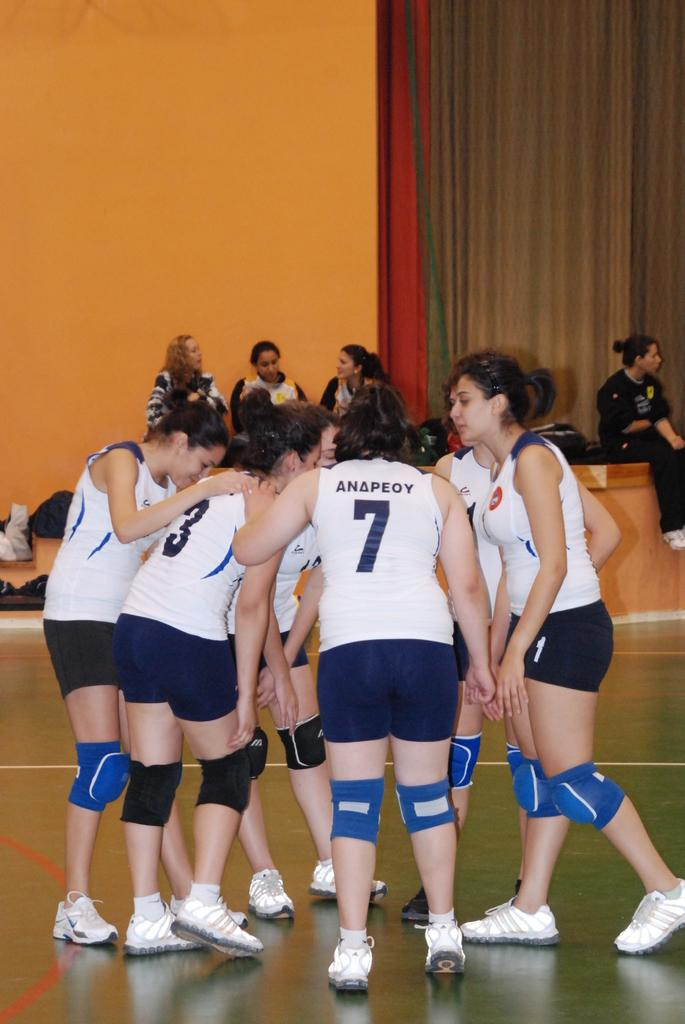<image>
Relay a brief, clear account of the picture shown. A team of volleyball players are huddled in a circle including number 3 and 7. 